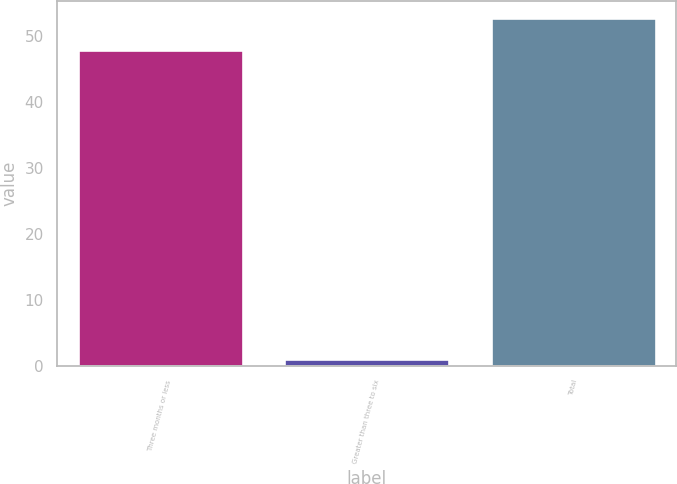Convert chart. <chart><loc_0><loc_0><loc_500><loc_500><bar_chart><fcel>Three months or less<fcel>Greater than three to six<fcel>Total<nl><fcel>48<fcel>1<fcel>52.8<nl></chart> 